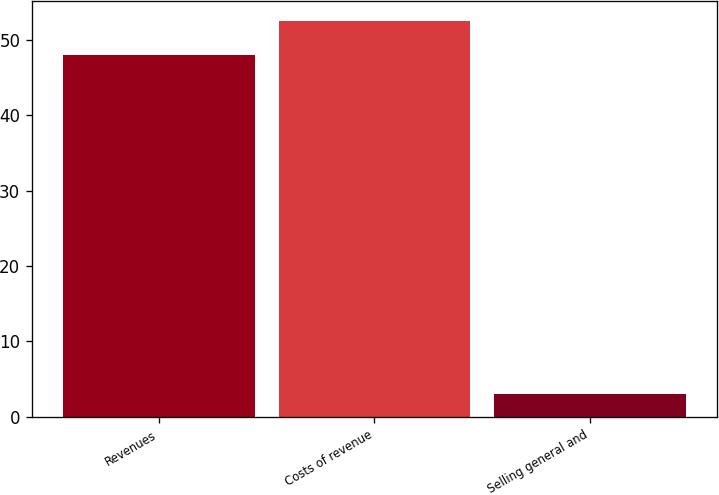<chart> <loc_0><loc_0><loc_500><loc_500><bar_chart><fcel>Revenues<fcel>Costs of revenue<fcel>Selling general and<nl><fcel>48<fcel>52.5<fcel>3<nl></chart> 